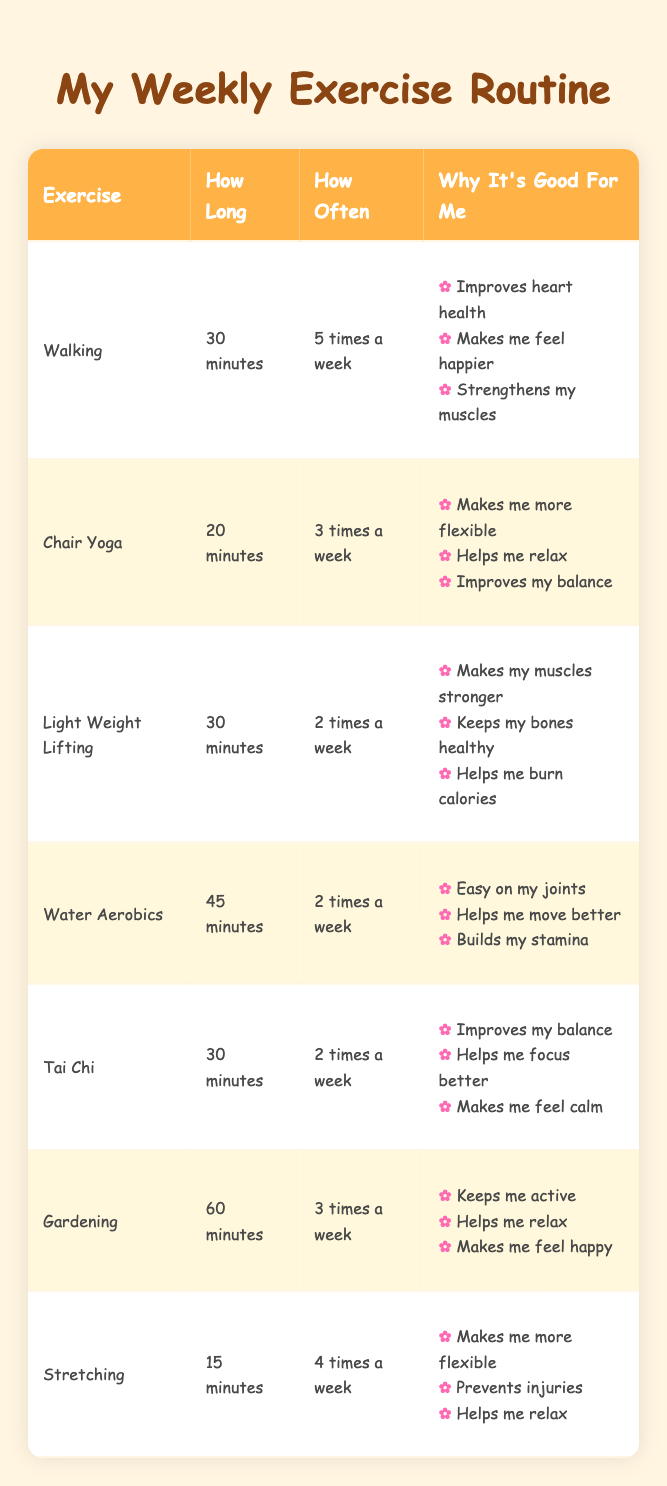What is the duration of Chair Yoga? Chair Yoga is listed in the table, and under "How Long," it states that the duration is 20 minutes.
Answer: 20 minutes How many times a week should one do Stretching? The table shows in the "How Often" column that Stretching is recommended to do 4 times a week.
Answer: 4 times a week Is Gardening beneficial for mood improvement? Looking at the "Why It's Good For Me" section for Gardening, it lists "Makes me feel happy," indicating it has a positive effect on mood.
Answer: Yes Which exercise has the longest duration and how long is it? The table shows the durations for each exercise, and Gardening has the longest duration at 60 minutes.
Answer: Gardening, 60 minutes What is the average duration of exercises done twice a week? The exercises done twice a week include Strength Training with Light Weights (30 minutes), Water Aerobics (45 minutes), and Tai Chi (30 minutes). We sum those durations (30 + 45 + 30 = 105) and divide by 3 to find the average of 105 / 3 = 35 minutes.
Answer: 35 minutes How many exercises improve flexibility? In the table, both Chair Yoga and Stretching are mentioned to improve flexibility, which indicates that there are 2 exercises that have this benefit.
Answer: 2 exercises Does Water Aerobics help improve joint mobility? Checking the "Why It's Good For Me" section for Water Aerobics, it lists "Helps me move better," which suggests it would support joint mobility.
Answer: Yes What is the least frequent exercise listed in the table? In the "How Often" column, Strength Training with Light Weights, Water Aerobics, and Tai Chi are each done 2 times a week, which is less frequent than the others.
Answer: Strength Training with Light Weights, Water Aerobics, Tai Chi (2 times a week) 